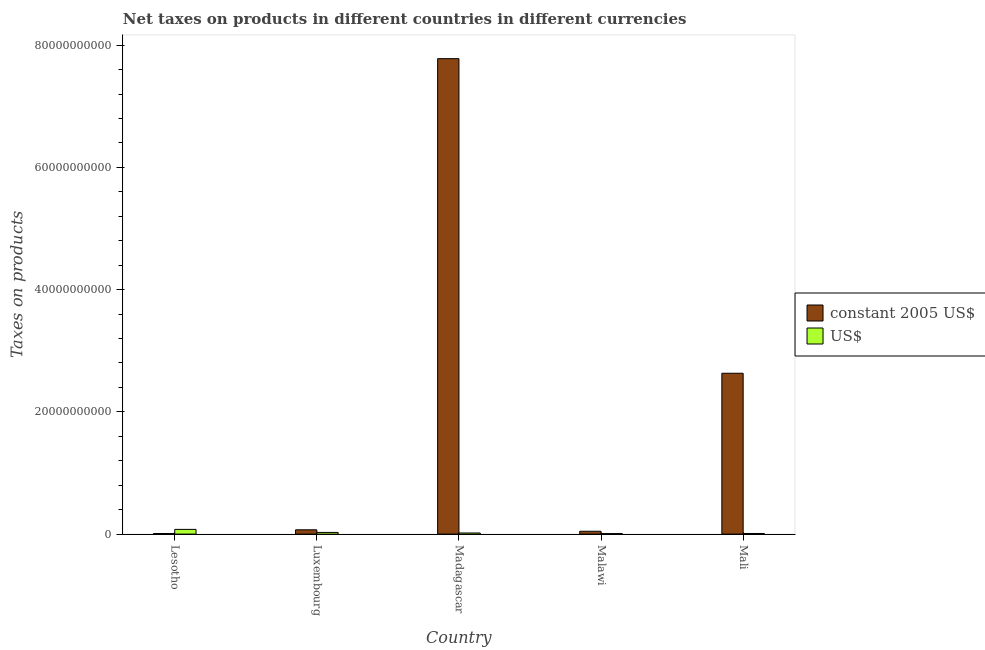What is the label of the 2nd group of bars from the left?
Provide a short and direct response. Luxembourg. What is the net taxes in constant 2005 us$ in Madagascar?
Keep it short and to the point. 7.78e+1. Across all countries, what is the maximum net taxes in constant 2005 us$?
Make the answer very short. 7.78e+1. Across all countries, what is the minimum net taxes in us$?
Give a very brief answer. 8.84e+07. In which country was the net taxes in us$ maximum?
Your answer should be very brief. Lesotho. In which country was the net taxes in constant 2005 us$ minimum?
Provide a succinct answer. Lesotho. What is the total net taxes in constant 2005 us$ in the graph?
Offer a very short reply. 1.05e+11. What is the difference between the net taxes in constant 2005 us$ in Malawi and that in Mali?
Your answer should be very brief. -2.59e+1. What is the difference between the net taxes in constant 2005 us$ in Madagascar and the net taxes in us$ in Luxembourg?
Ensure brevity in your answer.  7.75e+1. What is the average net taxes in constant 2005 us$ per country?
Provide a succinct answer. 2.11e+1. What is the difference between the net taxes in constant 2005 us$ and net taxes in us$ in Lesotho?
Your answer should be compact. -6.75e+08. In how many countries, is the net taxes in constant 2005 us$ greater than 44000000000 units?
Make the answer very short. 1. What is the ratio of the net taxes in constant 2005 us$ in Lesotho to that in Madagascar?
Provide a short and direct response. 0. Is the difference between the net taxes in us$ in Lesotho and Malawi greater than the difference between the net taxes in constant 2005 us$ in Lesotho and Malawi?
Make the answer very short. Yes. What is the difference between the highest and the second highest net taxes in constant 2005 us$?
Offer a very short reply. 5.15e+1. What is the difference between the highest and the lowest net taxes in us$?
Ensure brevity in your answer.  6.83e+08. In how many countries, is the net taxes in us$ greater than the average net taxes in us$ taken over all countries?
Offer a terse response. 1. What does the 2nd bar from the left in Luxembourg represents?
Ensure brevity in your answer.  US$. What does the 1st bar from the right in Madagascar represents?
Provide a succinct answer. US$. How many bars are there?
Your answer should be compact. 10. How many countries are there in the graph?
Your response must be concise. 5. What is the difference between two consecutive major ticks on the Y-axis?
Make the answer very short. 2.00e+1. Are the values on the major ticks of Y-axis written in scientific E-notation?
Keep it short and to the point. No. How are the legend labels stacked?
Ensure brevity in your answer.  Vertical. What is the title of the graph?
Give a very brief answer. Net taxes on products in different countries in different currencies. Does "Time to export" appear as one of the legend labels in the graph?
Provide a succinct answer. No. What is the label or title of the Y-axis?
Make the answer very short. Taxes on products. What is the Taxes on products in constant 2005 US$ in Lesotho?
Your answer should be very brief. 9.63e+07. What is the Taxes on products in US$ in Lesotho?
Keep it short and to the point. 7.71e+08. What is the Taxes on products of constant 2005 US$ in Luxembourg?
Offer a terse response. 7.03e+08. What is the Taxes on products in US$ in Luxembourg?
Your answer should be very brief. 2.76e+08. What is the Taxes on products of constant 2005 US$ in Madagascar?
Provide a succinct answer. 7.78e+1. What is the Taxes on products in US$ in Madagascar?
Keep it short and to the point. 1.82e+08. What is the Taxes on products of constant 2005 US$ in Malawi?
Your answer should be very brief. 4.66e+08. What is the Taxes on products of US$ in Malawi?
Provide a succinct answer. 8.84e+07. What is the Taxes on products in constant 2005 US$ in Mali?
Ensure brevity in your answer.  2.63e+1. What is the Taxes on products of US$ in Mali?
Provide a succinct answer. 1.01e+08. Across all countries, what is the maximum Taxes on products in constant 2005 US$?
Provide a succinct answer. 7.78e+1. Across all countries, what is the maximum Taxes on products of US$?
Provide a succinct answer. 7.71e+08. Across all countries, what is the minimum Taxes on products in constant 2005 US$?
Offer a very short reply. 9.63e+07. Across all countries, what is the minimum Taxes on products in US$?
Offer a very short reply. 8.84e+07. What is the total Taxes on products in constant 2005 US$ in the graph?
Your response must be concise. 1.05e+11. What is the total Taxes on products of US$ in the graph?
Your answer should be compact. 1.42e+09. What is the difference between the Taxes on products in constant 2005 US$ in Lesotho and that in Luxembourg?
Offer a very short reply. -6.06e+08. What is the difference between the Taxes on products in US$ in Lesotho and that in Luxembourg?
Offer a very short reply. 4.95e+08. What is the difference between the Taxes on products of constant 2005 US$ in Lesotho and that in Madagascar?
Your response must be concise. -7.77e+1. What is the difference between the Taxes on products of US$ in Lesotho and that in Madagascar?
Offer a very short reply. 5.89e+08. What is the difference between the Taxes on products of constant 2005 US$ in Lesotho and that in Malawi?
Provide a short and direct response. -3.70e+08. What is the difference between the Taxes on products of US$ in Lesotho and that in Malawi?
Provide a short and direct response. 6.83e+08. What is the difference between the Taxes on products in constant 2005 US$ in Lesotho and that in Mali?
Your answer should be very brief. -2.62e+1. What is the difference between the Taxes on products in US$ in Lesotho and that in Mali?
Your answer should be compact. 6.71e+08. What is the difference between the Taxes on products in constant 2005 US$ in Luxembourg and that in Madagascar?
Give a very brief answer. -7.71e+1. What is the difference between the Taxes on products of US$ in Luxembourg and that in Madagascar?
Provide a succinct answer. 9.46e+07. What is the difference between the Taxes on products of constant 2005 US$ in Luxembourg and that in Malawi?
Give a very brief answer. 2.37e+08. What is the difference between the Taxes on products in US$ in Luxembourg and that in Malawi?
Keep it short and to the point. 1.88e+08. What is the difference between the Taxes on products in constant 2005 US$ in Luxembourg and that in Mali?
Give a very brief answer. -2.56e+1. What is the difference between the Taxes on products in US$ in Luxembourg and that in Mali?
Provide a succinct answer. 1.76e+08. What is the difference between the Taxes on products of constant 2005 US$ in Madagascar and that in Malawi?
Give a very brief answer. 7.73e+1. What is the difference between the Taxes on products in US$ in Madagascar and that in Malawi?
Your response must be concise. 9.35e+07. What is the difference between the Taxes on products of constant 2005 US$ in Madagascar and that in Mali?
Ensure brevity in your answer.  5.15e+1. What is the difference between the Taxes on products in US$ in Madagascar and that in Mali?
Offer a terse response. 8.14e+07. What is the difference between the Taxes on products of constant 2005 US$ in Malawi and that in Mali?
Keep it short and to the point. -2.59e+1. What is the difference between the Taxes on products in US$ in Malawi and that in Mali?
Give a very brief answer. -1.22e+07. What is the difference between the Taxes on products of constant 2005 US$ in Lesotho and the Taxes on products of US$ in Luxembourg?
Your answer should be compact. -1.80e+08. What is the difference between the Taxes on products in constant 2005 US$ in Lesotho and the Taxes on products in US$ in Madagascar?
Offer a terse response. -8.56e+07. What is the difference between the Taxes on products in constant 2005 US$ in Lesotho and the Taxes on products in US$ in Malawi?
Ensure brevity in your answer.  7.97e+06. What is the difference between the Taxes on products in constant 2005 US$ in Lesotho and the Taxes on products in US$ in Mali?
Your response must be concise. -4.19e+06. What is the difference between the Taxes on products of constant 2005 US$ in Luxembourg and the Taxes on products of US$ in Madagascar?
Provide a short and direct response. 5.21e+08. What is the difference between the Taxes on products of constant 2005 US$ in Luxembourg and the Taxes on products of US$ in Malawi?
Make the answer very short. 6.14e+08. What is the difference between the Taxes on products in constant 2005 US$ in Luxembourg and the Taxes on products in US$ in Mali?
Give a very brief answer. 6.02e+08. What is the difference between the Taxes on products in constant 2005 US$ in Madagascar and the Taxes on products in US$ in Malawi?
Provide a short and direct response. 7.77e+1. What is the difference between the Taxes on products in constant 2005 US$ in Madagascar and the Taxes on products in US$ in Mali?
Your answer should be compact. 7.77e+1. What is the difference between the Taxes on products of constant 2005 US$ in Malawi and the Taxes on products of US$ in Mali?
Provide a succinct answer. 3.65e+08. What is the average Taxes on products in constant 2005 US$ per country?
Keep it short and to the point. 2.11e+1. What is the average Taxes on products of US$ per country?
Offer a terse response. 2.84e+08. What is the difference between the Taxes on products in constant 2005 US$ and Taxes on products in US$ in Lesotho?
Provide a short and direct response. -6.75e+08. What is the difference between the Taxes on products in constant 2005 US$ and Taxes on products in US$ in Luxembourg?
Offer a terse response. 4.26e+08. What is the difference between the Taxes on products of constant 2005 US$ and Taxes on products of US$ in Madagascar?
Give a very brief answer. 7.76e+1. What is the difference between the Taxes on products of constant 2005 US$ and Taxes on products of US$ in Malawi?
Your answer should be compact. 3.78e+08. What is the difference between the Taxes on products in constant 2005 US$ and Taxes on products in US$ in Mali?
Your response must be concise. 2.62e+1. What is the ratio of the Taxes on products in constant 2005 US$ in Lesotho to that in Luxembourg?
Your answer should be very brief. 0.14. What is the ratio of the Taxes on products in US$ in Lesotho to that in Luxembourg?
Offer a terse response. 2.79. What is the ratio of the Taxes on products of constant 2005 US$ in Lesotho to that in Madagascar?
Keep it short and to the point. 0. What is the ratio of the Taxes on products of US$ in Lesotho to that in Madagascar?
Provide a short and direct response. 4.24. What is the ratio of the Taxes on products in constant 2005 US$ in Lesotho to that in Malawi?
Your answer should be very brief. 0.21. What is the ratio of the Taxes on products in US$ in Lesotho to that in Malawi?
Offer a very short reply. 8.73. What is the ratio of the Taxes on products of constant 2005 US$ in Lesotho to that in Mali?
Keep it short and to the point. 0. What is the ratio of the Taxes on products in US$ in Lesotho to that in Mali?
Your answer should be very brief. 7.67. What is the ratio of the Taxes on products of constant 2005 US$ in Luxembourg to that in Madagascar?
Your answer should be compact. 0.01. What is the ratio of the Taxes on products of US$ in Luxembourg to that in Madagascar?
Offer a terse response. 1.52. What is the ratio of the Taxes on products of constant 2005 US$ in Luxembourg to that in Malawi?
Provide a short and direct response. 1.51. What is the ratio of the Taxes on products in US$ in Luxembourg to that in Malawi?
Your answer should be compact. 3.13. What is the ratio of the Taxes on products of constant 2005 US$ in Luxembourg to that in Mali?
Offer a very short reply. 0.03. What is the ratio of the Taxes on products of US$ in Luxembourg to that in Mali?
Provide a succinct answer. 2.75. What is the ratio of the Taxes on products in constant 2005 US$ in Madagascar to that in Malawi?
Your answer should be compact. 166.99. What is the ratio of the Taxes on products in US$ in Madagascar to that in Malawi?
Your answer should be compact. 2.06. What is the ratio of the Taxes on products in constant 2005 US$ in Madagascar to that in Mali?
Offer a terse response. 2.96. What is the ratio of the Taxes on products in US$ in Madagascar to that in Mali?
Your response must be concise. 1.81. What is the ratio of the Taxes on products in constant 2005 US$ in Malawi to that in Mali?
Provide a short and direct response. 0.02. What is the ratio of the Taxes on products of US$ in Malawi to that in Mali?
Give a very brief answer. 0.88. What is the difference between the highest and the second highest Taxes on products of constant 2005 US$?
Provide a succinct answer. 5.15e+1. What is the difference between the highest and the second highest Taxes on products of US$?
Your answer should be compact. 4.95e+08. What is the difference between the highest and the lowest Taxes on products of constant 2005 US$?
Give a very brief answer. 7.77e+1. What is the difference between the highest and the lowest Taxes on products in US$?
Provide a succinct answer. 6.83e+08. 